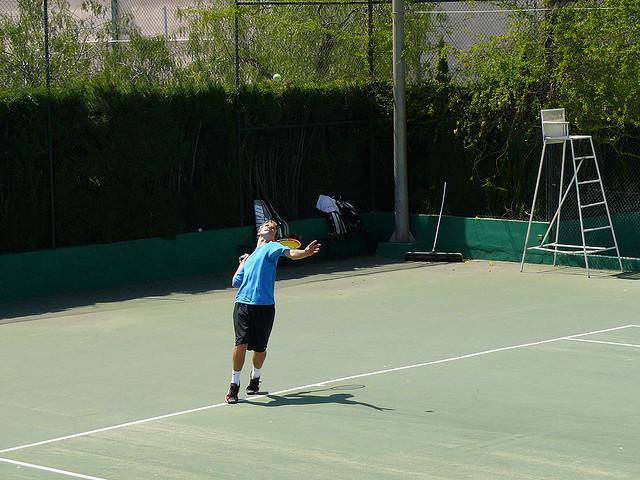Are the trees depicted deciduous?
Short answer required. Yes. What time is it?
Answer briefly. Daytime. Is too sunny to be playing tennis outside?
Give a very brief answer. No. What is the tennis court next to?
Short answer required. Trees. What sport is it?
Give a very brief answer. Tennis. 